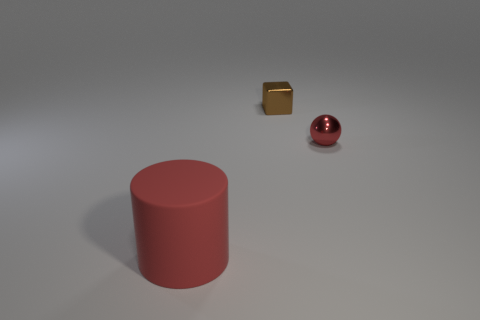Subtract all cubes. How many objects are left? 2 Add 1 tiny balls. How many tiny balls exist? 2 Add 2 green shiny spheres. How many objects exist? 5 Subtract 0 yellow blocks. How many objects are left? 3 Subtract all cyan spheres. Subtract all gray cylinders. How many spheres are left? 1 Subtract all purple cubes. How many cyan cylinders are left? 0 Subtract all metal spheres. Subtract all large red matte things. How many objects are left? 1 Add 1 red objects. How many red objects are left? 3 